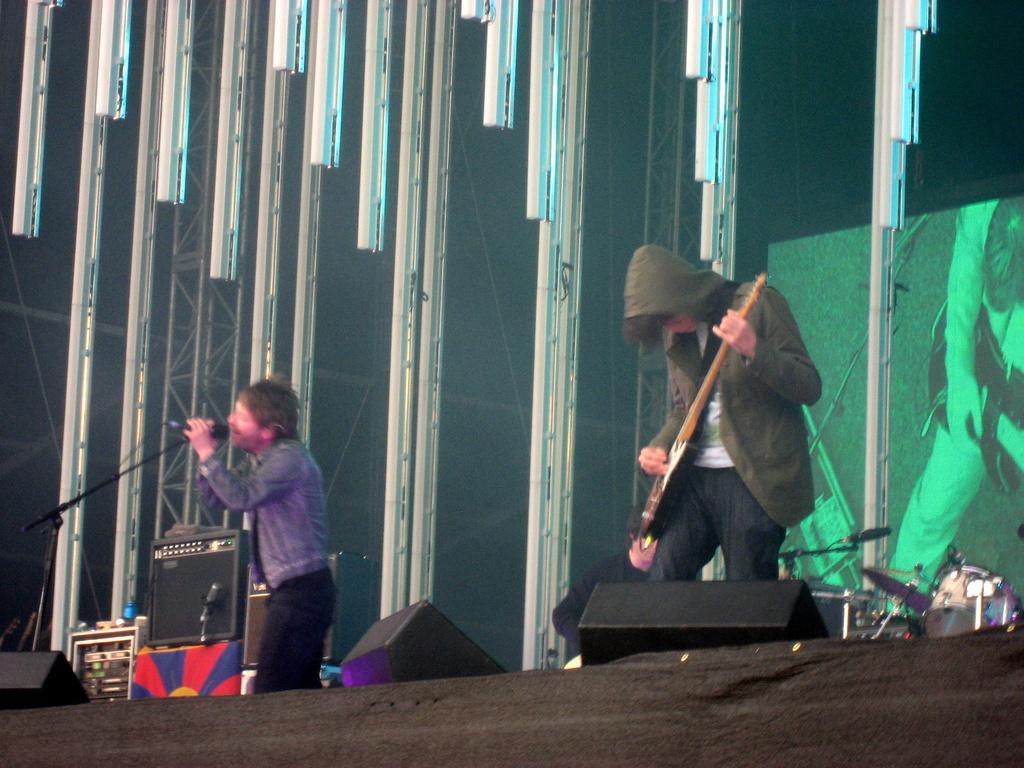How would you summarize this image in a sentence or two? Here a man is singing on a microphone and in the right side a man is playing the guitar. behind them there is a screen down there is a light. 